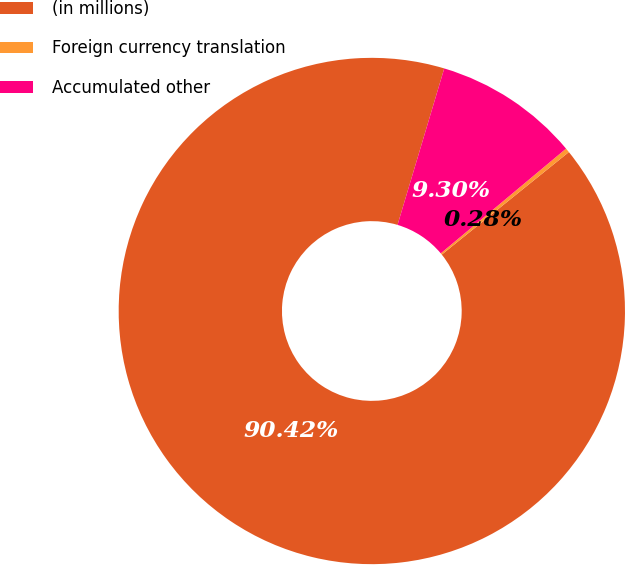<chart> <loc_0><loc_0><loc_500><loc_500><pie_chart><fcel>(in millions)<fcel>Foreign currency translation<fcel>Accumulated other<nl><fcel>90.42%<fcel>0.28%<fcel>9.3%<nl></chart> 